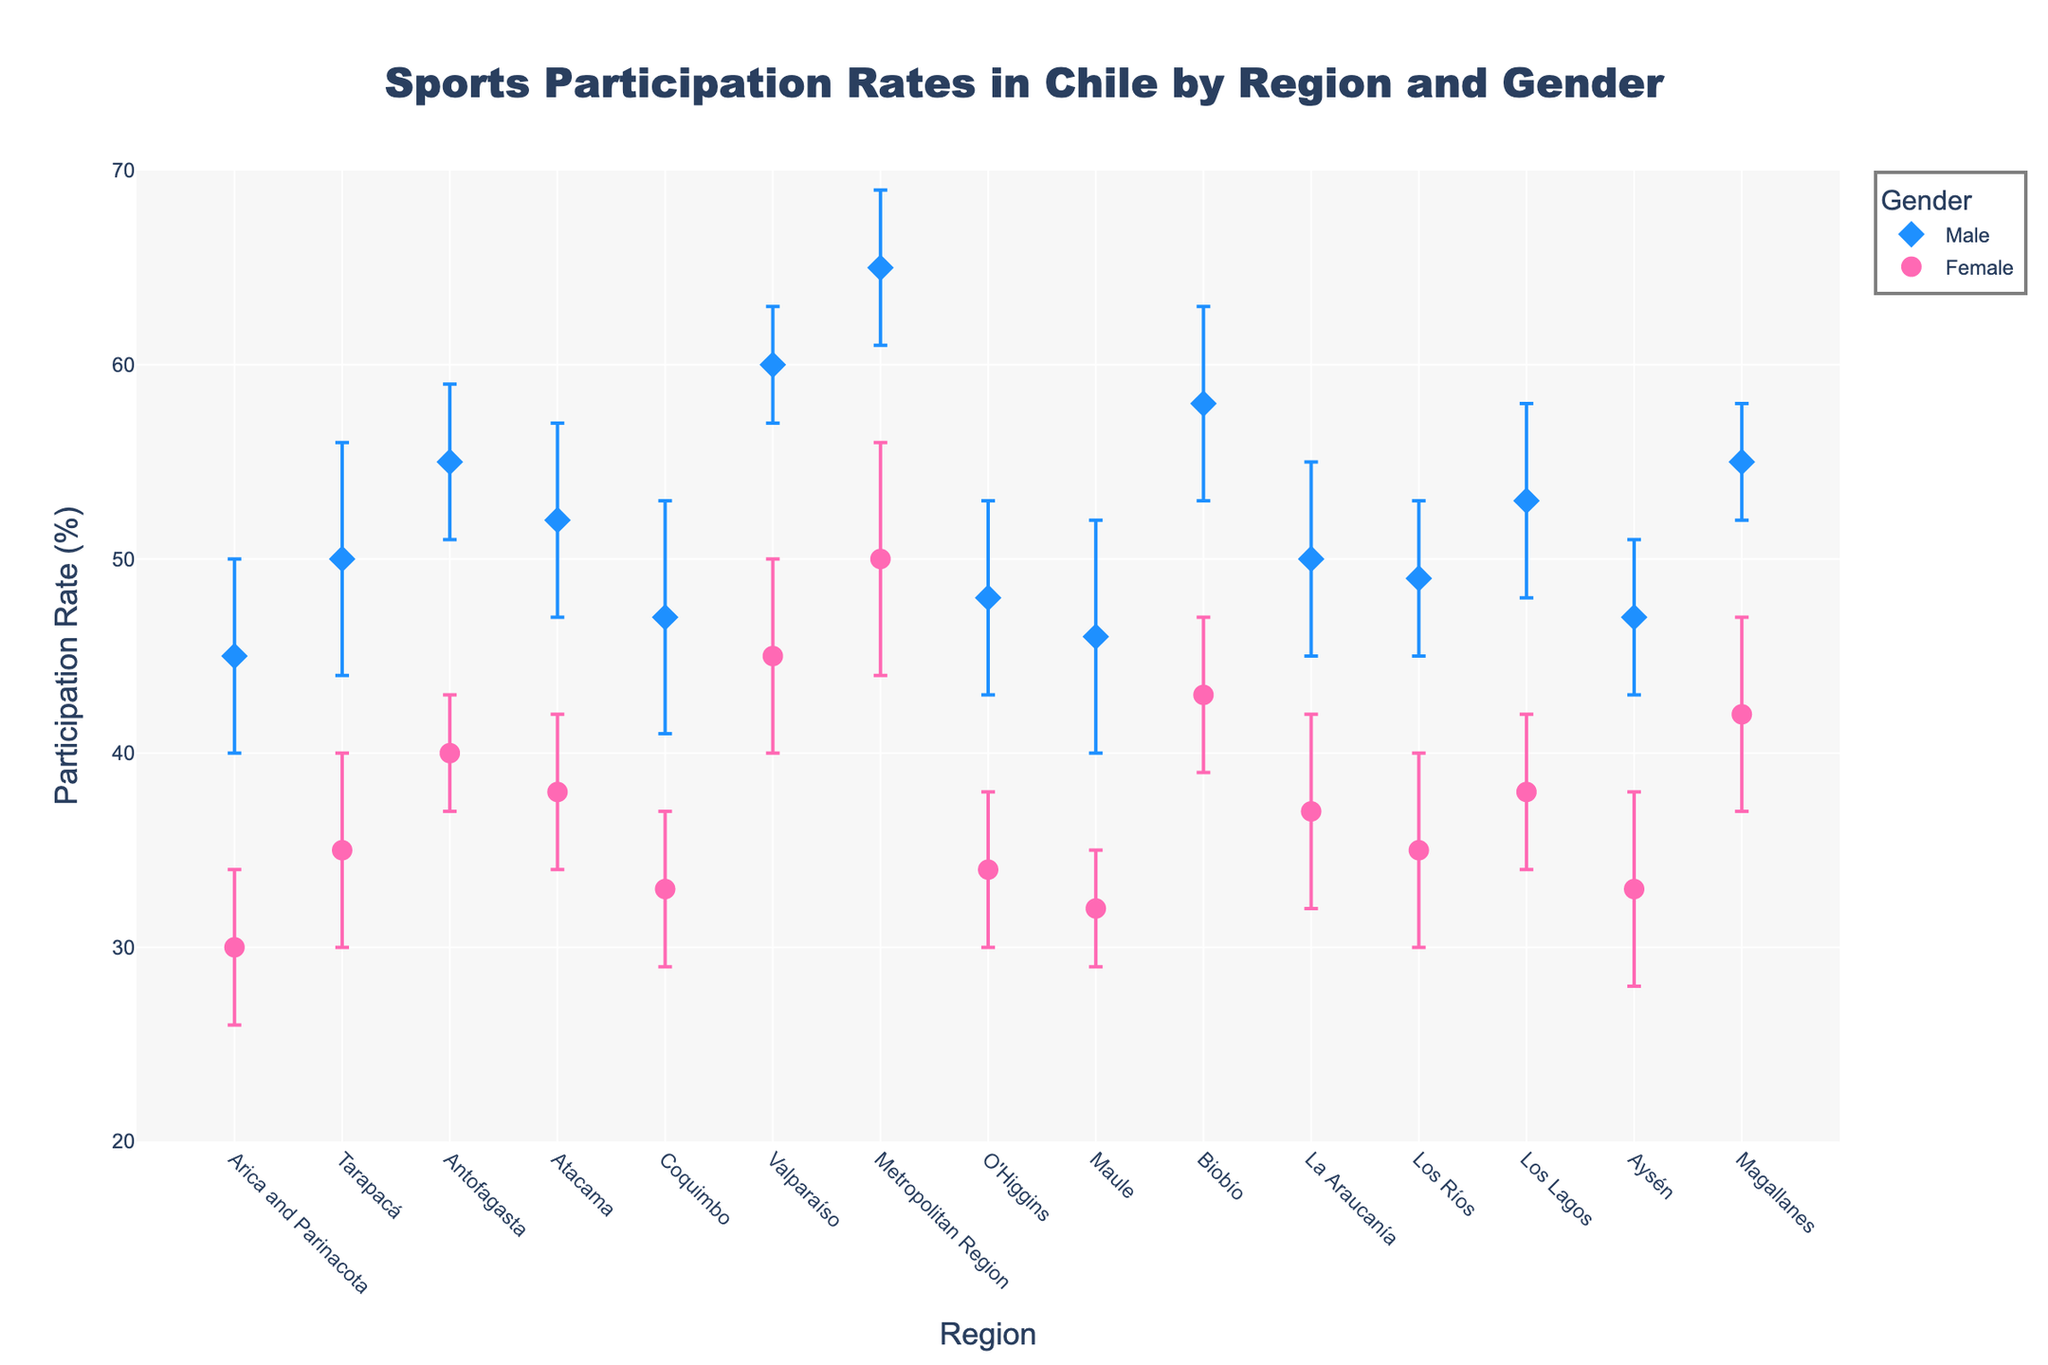what is the title of the plot? The title text of the plot is typically found at the top of the figure, clearly indicating what the plot represents.
Answer: Sports Participation Rates in Chile by Region and Gender Which region has the highest participation rate among males? Look for the male data points illustrated by diamond markers on the plot and identify the region with the marker at the highest position on the y-axis.
Answer: Metropolitan Region What is the participation rate difference between males and females in the Valparaíso region? First, find the data points for both genders in the Valparaíso region. Note their y-values (participation rates) and calculate the difference: 60% (male) - 45% (female) = 15%.
Answer: 15% Which region has the lowest female participation rate and what is it? Identify the female markers (circle) on the plot and find the one at the lowest y-value, then check the corresponding region.
Answer: Maule, 32% On average, are male participation rates higher than female participation rates across all regions? Calculate the average participation rates for males and females respectively by summing the y-values of each gender's data points and dividing by the number of data points, then compare the averages.
Answer: Yes How does the participation rate variability (considering error bars) for males in the Tarapacá region compare to females in the same region? Identify the size of error bars for both genders in the Tarapacá region. Males have an error bar of ±6%, while females have ±5%.
Answer: Males have higher variability In which region do males and females have the smallest difference in participation rates? Check the differences in participation rates for all regions and find the smallest difference by comparing each one.
Answer: Los Ríos, 14% Are there any regions where the female participation rate exceeds 40%? If yes, name them. Identify the female data points above the 40% mark on the y-axis and note their corresponding regions.
Answer: Antofagasta, Biobío, Metropolitan Region, Valparaíso, Magallanes What is the trend of male participation rates across the regions from Arica and Parinacota to Magallanes? Observe the positions of the male markers (diamond) across the x-axis regions from left to right, noting if they primarily increase, decrease, or have no clear trend.
Answer: Generally increasing 